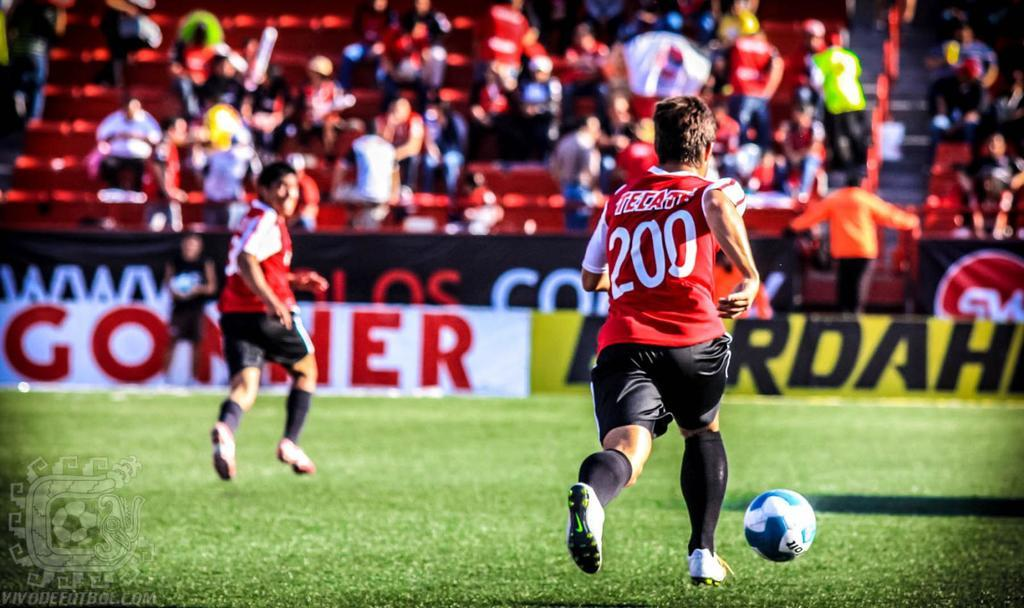What is happening in the front of the image? Two men are playing football in the front of the image. What can be seen in the background of the image? There are many people in the background of the image. What type of surface are the men playing football on? There is green grass at the bottom of the image. How many pizzas are being served to the vegetable in the image? There are no pizzas or vegetables present in the image. What type of horn can be heard in the background of the image? There is no horn present in the image, and no sound can be heard from the image. 